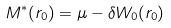Convert formula to latex. <formula><loc_0><loc_0><loc_500><loc_500>M ^ { * } ( r _ { 0 } ) = \mu - \delta W _ { 0 } ( r _ { 0 } )</formula> 